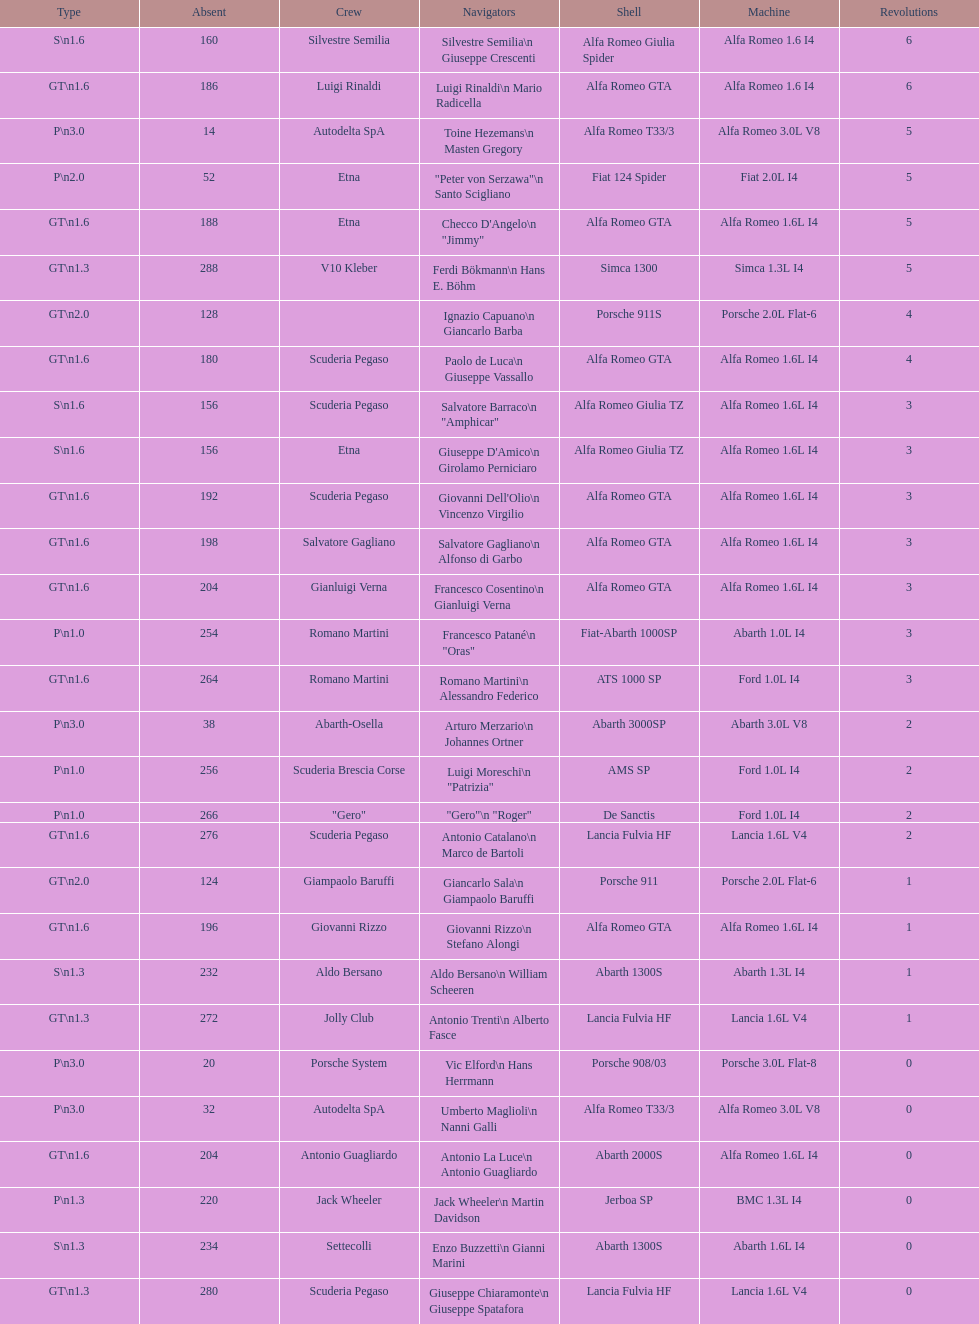How many laps does v10 kleber have? 5. 